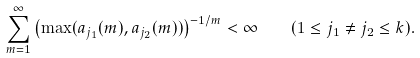Convert formula to latex. <formula><loc_0><loc_0><loc_500><loc_500>\sum _ { m = 1 } ^ { \infty } \left ( \max ( a _ { j _ { 1 } } ( m ) , a _ { j _ { 2 } } ( m ) ) \right ) ^ { - 1 / m } < \infty \quad ( 1 \leq j _ { 1 } \neq j _ { 2 } \leq k ) .</formula> 